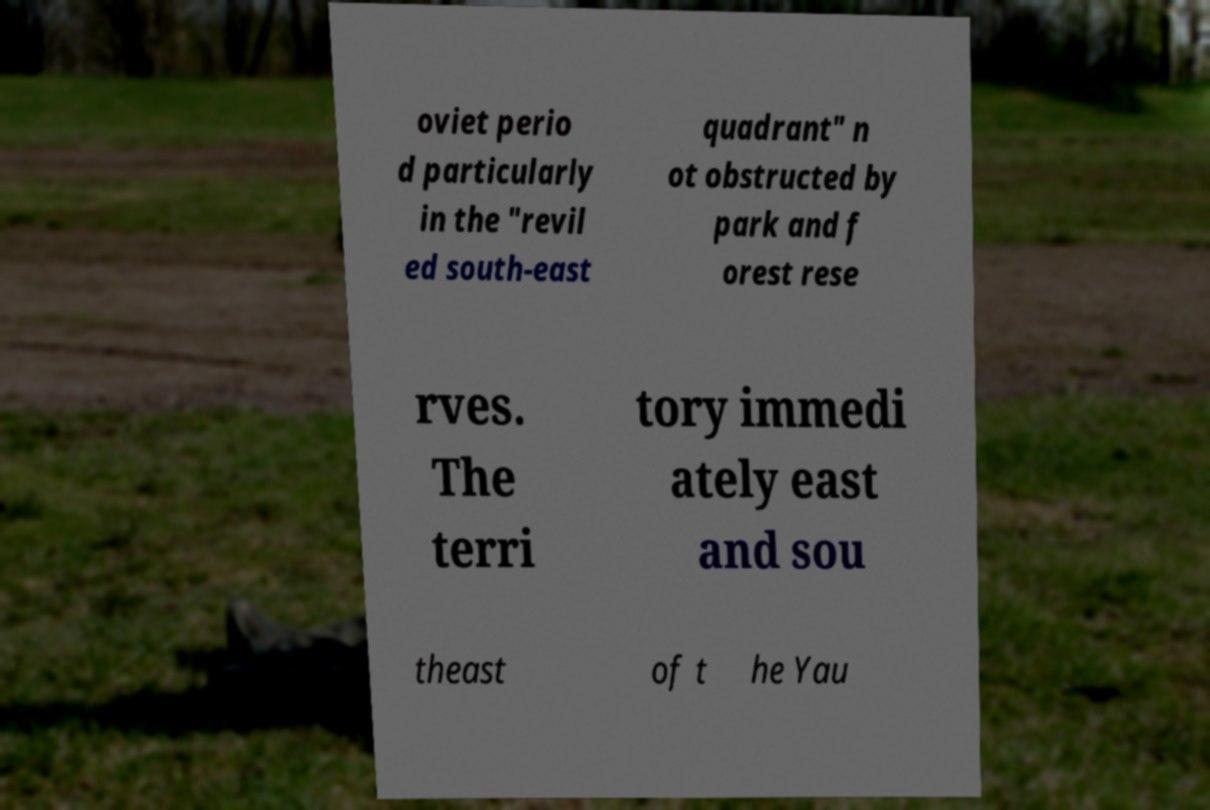For documentation purposes, I need the text within this image transcribed. Could you provide that? oviet perio d particularly in the "revil ed south-east quadrant" n ot obstructed by park and f orest rese rves. The terri tory immedi ately east and sou theast of t he Yau 